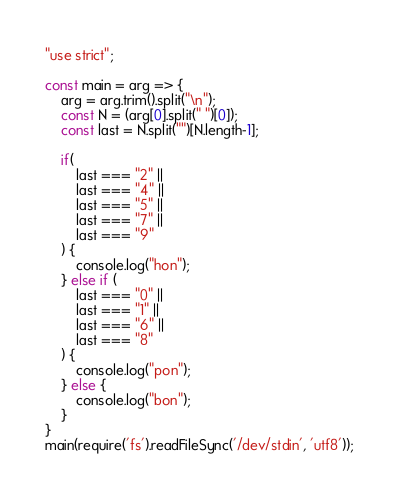Convert code to text. <code><loc_0><loc_0><loc_500><loc_500><_JavaScript_>"use strict";
    
const main = arg => {
    arg = arg.trim().split("\n");
    const N = (arg[0].split(" ")[0]);
    const last = N.split("")[N.length-1];
    
    if(
        last === "2" ||
        last === "4" ||
        last === "5" ||
        last === "7" ||
        last === "9"
    ) {
        console.log("hon");
    } else if (
        last === "0" ||
        last === "1" ||
        last === "6" ||
        last === "8"
    ) {
        console.log("pon");
    } else {
        console.log("bon");
    }
}
main(require('fs').readFileSync('/dev/stdin', 'utf8'));</code> 